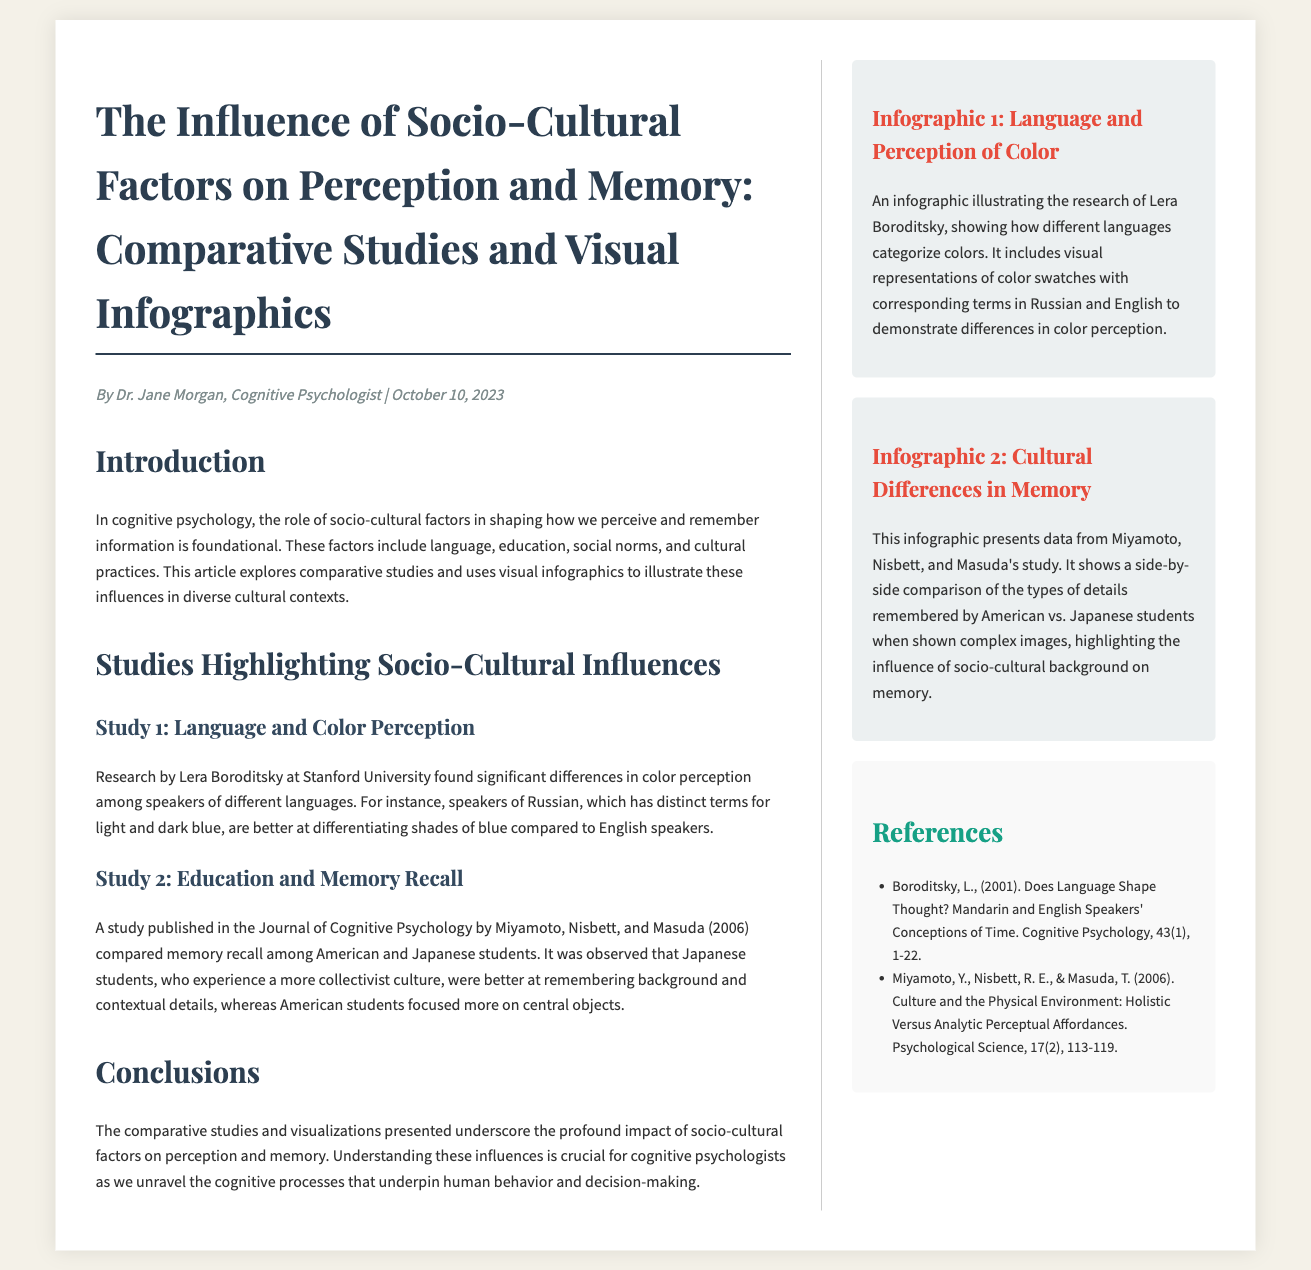What is the title of the article? The title is prominently displayed at the beginning of the document, summarizing the topic discussed.
Answer: The Influence of Socio-Cultural Factors on Perception and Memory: Comparative Studies and Visual Infographics Who authored the article? The author's name is mentioned in the meta section of the document, stating who wrote the article.
Answer: Dr. Jane Morgan When was the article published? The publication date is also included in the meta section, giving readers insight into when the research was shared.
Answer: October 10, 2023 What is the first study discussed in the article? The first study is presented under a subheading that clearly identifies it as the initial research example.
Answer: Language and Color Perception Which researchers conducted the second study? The researchers' names are mentioned in the study section, identifying who was involved in the research.
Answer: Miyamoto, Nisbett, and Masuda What does Infographic 1 illustrate? The title of Infographic 1 indicates what specific topic it visually represents, making it easy to identify.
Answer: Language and Perception of Color How do Japanese students perform in terms of memory recall according to the second study? This information is included in the findings and highlights the distinct behaviors observed in the comparative study.
Answer: Better at remembering background and contextual details What cultural aspect influences memory types remembered by students? The article specifically states the cultural context that shapes the memory recall behavior of different groups.
Answer: Socio-cultural background 